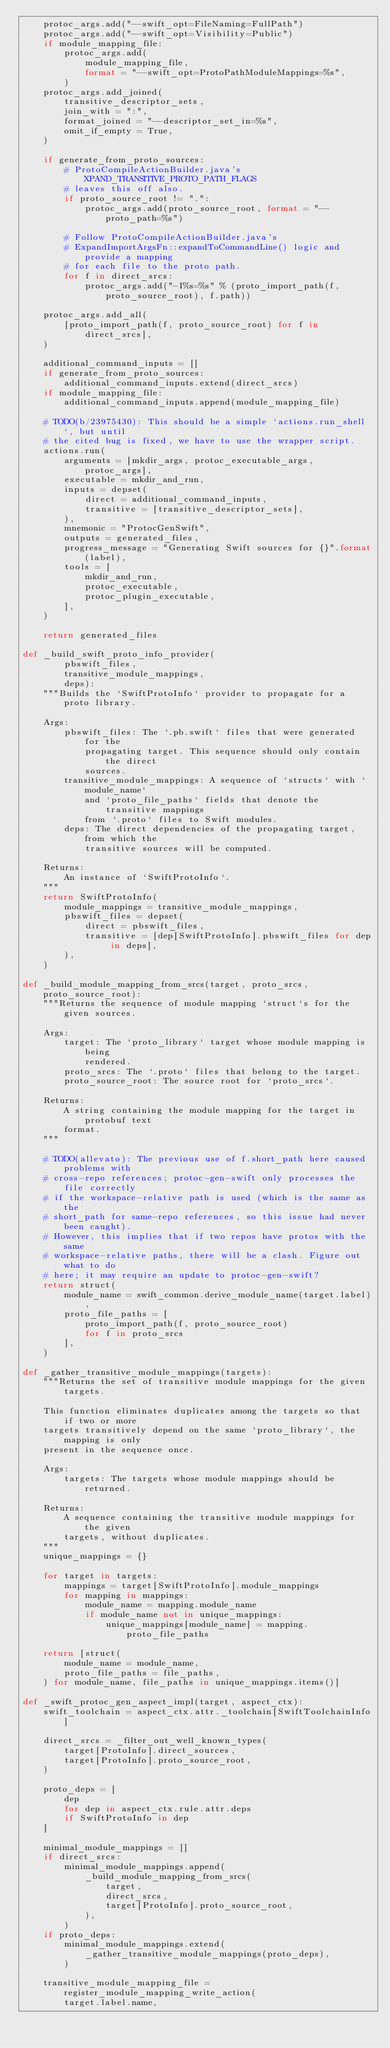Convert code to text. <code><loc_0><loc_0><loc_500><loc_500><_Python_>    protoc_args.add("--swift_opt=FileNaming=FullPath")
    protoc_args.add("--swift_opt=Visibility=Public")
    if module_mapping_file:
        protoc_args.add(
            module_mapping_file,
            format = "--swift_opt=ProtoPathModuleMappings=%s",
        )
    protoc_args.add_joined(
        transitive_descriptor_sets,
        join_with = ":",
        format_joined = "--descriptor_set_in=%s",
        omit_if_empty = True,
    )

    if generate_from_proto_sources:
        # ProtoCompileActionBuilder.java's XPAND_TRANSITIVE_PROTO_PATH_FLAGS
        # leaves this off also.
        if proto_source_root != ".":
            protoc_args.add(proto_source_root, format = "--proto_path=%s")

        # Follow ProtoCompileActionBuilder.java's
        # ExpandImportArgsFn::expandToCommandLine() logic and provide a mapping
        # for each file to the proto path.
        for f in direct_srcs:
            protoc_args.add("-I%s=%s" % (proto_import_path(f, proto_source_root), f.path))

    protoc_args.add_all(
        [proto_import_path(f, proto_source_root) for f in direct_srcs],
    )

    additional_command_inputs = []
    if generate_from_proto_sources:
        additional_command_inputs.extend(direct_srcs)
    if module_mapping_file:
        additional_command_inputs.append(module_mapping_file)

    # TODO(b/23975430): This should be a simple `actions.run_shell`, but until
    # the cited bug is fixed, we have to use the wrapper script.
    actions.run(
        arguments = [mkdir_args, protoc_executable_args, protoc_args],
        executable = mkdir_and_run,
        inputs = depset(
            direct = additional_command_inputs,
            transitive = [transitive_descriptor_sets],
        ),
        mnemonic = "ProtocGenSwift",
        outputs = generated_files,
        progress_message = "Generating Swift sources for {}".format(label),
        tools = [
            mkdir_and_run,
            protoc_executable,
            protoc_plugin_executable,
        ],
    )

    return generated_files

def _build_swift_proto_info_provider(
        pbswift_files,
        transitive_module_mappings,
        deps):
    """Builds the `SwiftProtoInfo` provider to propagate for a proto library.

    Args:
        pbswift_files: The `.pb.swift` files that were generated for the
            propagating target. This sequence should only contain the direct
            sources.
        transitive_module_mappings: A sequence of `structs` with `module_name`
            and `proto_file_paths` fields that denote the transitive mappings
            from `.proto` files to Swift modules.
        deps: The direct dependencies of the propagating target, from which the
            transitive sources will be computed.

    Returns:
        An instance of `SwiftProtoInfo`.
    """
    return SwiftProtoInfo(
        module_mappings = transitive_module_mappings,
        pbswift_files = depset(
            direct = pbswift_files,
            transitive = [dep[SwiftProtoInfo].pbswift_files for dep in deps],
        ),
    )

def _build_module_mapping_from_srcs(target, proto_srcs, proto_source_root):
    """Returns the sequence of module mapping `struct`s for the given sources.

    Args:
        target: The `proto_library` target whose module mapping is being
            rendered.
        proto_srcs: The `.proto` files that belong to the target.
        proto_source_root: The source root for `proto_srcs`.

    Returns:
        A string containing the module mapping for the target in protobuf text
        format.
    """

    # TODO(allevato): The previous use of f.short_path here caused problems with
    # cross-repo references; protoc-gen-swift only processes the file correctly
    # if the workspace-relative path is used (which is the same as the
    # short_path for same-repo references, so this issue had never been caught).
    # However, this implies that if two repos have protos with the same
    # workspace-relative paths, there will be a clash. Figure out what to do
    # here; it may require an update to protoc-gen-swift?
    return struct(
        module_name = swift_common.derive_module_name(target.label),
        proto_file_paths = [
            proto_import_path(f, proto_source_root)
            for f in proto_srcs
        ],
    )

def _gather_transitive_module_mappings(targets):
    """Returns the set of transitive module mappings for the given targets.

    This function eliminates duplicates among the targets so that if two or more
    targets transitively depend on the same `proto_library`, the mapping is only
    present in the sequence once.

    Args:
        targets: The targets whose module mappings should be returned.

    Returns:
        A sequence containing the transitive module mappings for the given
        targets, without duplicates.
    """
    unique_mappings = {}

    for target in targets:
        mappings = target[SwiftProtoInfo].module_mappings
        for mapping in mappings:
            module_name = mapping.module_name
            if module_name not in unique_mappings:
                unique_mappings[module_name] = mapping.proto_file_paths

    return [struct(
        module_name = module_name,
        proto_file_paths = file_paths,
    ) for module_name, file_paths in unique_mappings.items()]

def _swift_protoc_gen_aspect_impl(target, aspect_ctx):
    swift_toolchain = aspect_ctx.attr._toolchain[SwiftToolchainInfo]

    direct_srcs = _filter_out_well_known_types(
        target[ProtoInfo].direct_sources,
        target[ProtoInfo].proto_source_root,
    )

    proto_deps = [
        dep
        for dep in aspect_ctx.rule.attr.deps
        if SwiftProtoInfo in dep
    ]

    minimal_module_mappings = []
    if direct_srcs:
        minimal_module_mappings.append(
            _build_module_mapping_from_srcs(
                target,
                direct_srcs,
                target[ProtoInfo].proto_source_root,
            ),
        )
    if proto_deps:
        minimal_module_mappings.extend(
            _gather_transitive_module_mappings(proto_deps),
        )

    transitive_module_mapping_file = register_module_mapping_write_action(
        target.label.name,</code> 